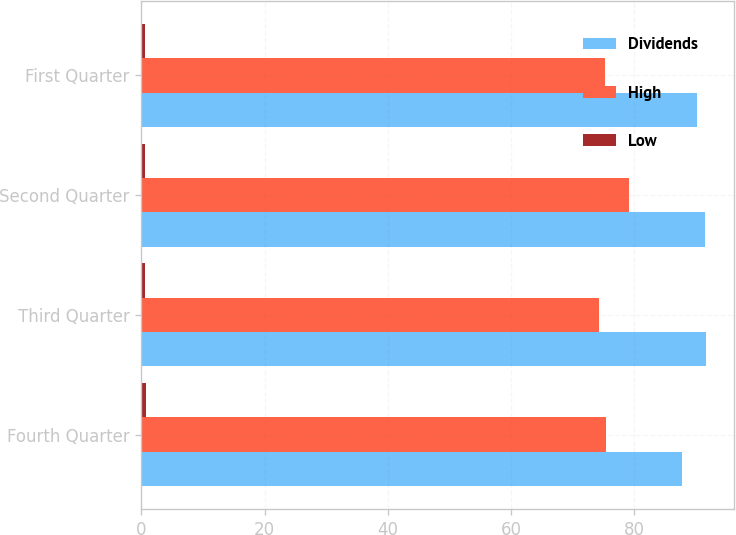Convert chart. <chart><loc_0><loc_0><loc_500><loc_500><stacked_bar_chart><ecel><fcel>Fourth Quarter<fcel>Third Quarter<fcel>Second Quarter<fcel>First Quarter<nl><fcel>Dividends<fcel>87.69<fcel>91.68<fcel>91.47<fcel>90.11<nl><fcel>High<fcel>75.4<fcel>74.22<fcel>79.13<fcel>75.32<nl><fcel>Low<fcel>0.7<fcel>0.58<fcel>0.58<fcel>0.58<nl></chart> 